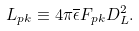<formula> <loc_0><loc_0><loc_500><loc_500>L _ { p k } \equiv 4 \pi \overline { \epsilon } F _ { p k } D _ { L } ^ { 2 } .</formula> 